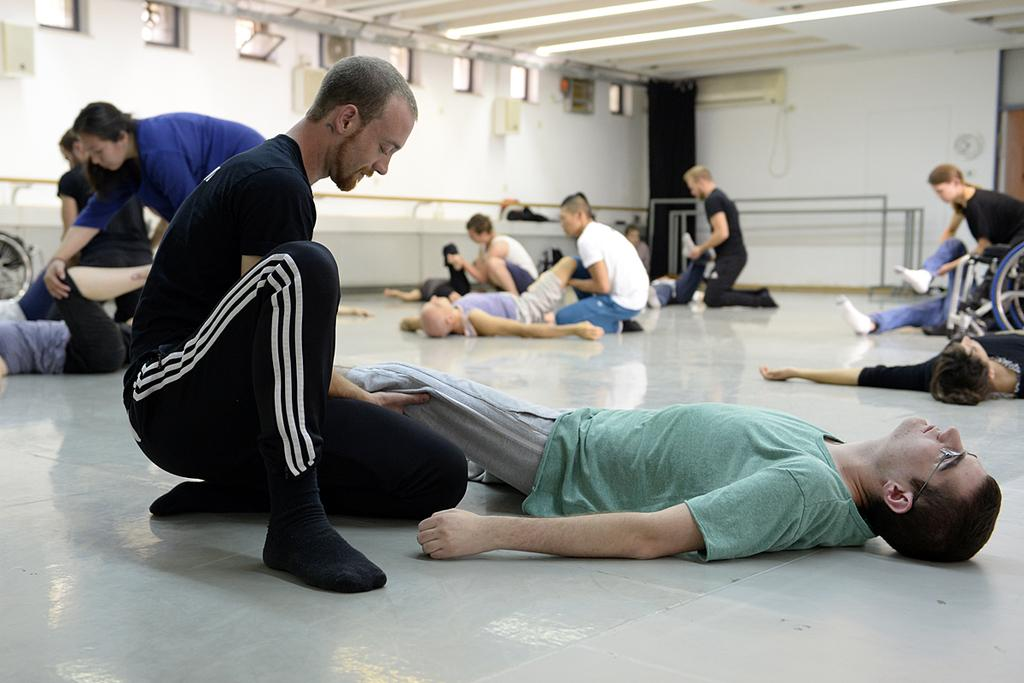What are the people on the floor doing in the image? There are many people lying on the floor, and some people are doing physiotherapy for these people. Can you describe the people providing assistance in the image? The people providing assistance are doing physiotherapy for the people lying on the floor. What can be seen in the background of the image? There is a wall with ventilation in the background. Where is the hen in the image? There is no hen present in the image. What type of bee can be seen buzzing around the people on the floor? There are no bees present in the image. 